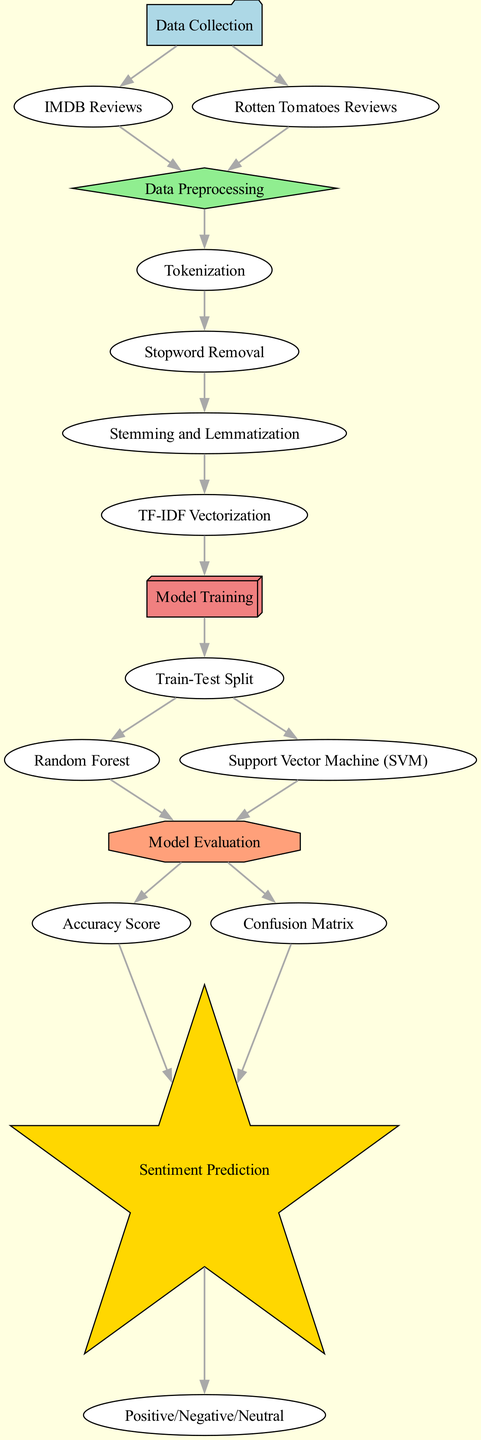What are the two sources of data collection? The diagram shows two sources for data collection: IMDB Reviews and Rotten Tomatoes Reviews as indicated by the edges leading from the "Data Collection" node to both sources.
Answer: IMDB Reviews, Rotten Tomatoes Reviews How many preprocessing steps are there in the diagram? The diagram includes four distinct steps labeled Tokenization, Stopword Removal, Stemming and Lemmatization, and TF-IDF Vectorization, which can be counted directly from the nodes connected to the Data Preprocessing node.
Answer: Four Which model training techniques are used in the diagram? The diagram specifies two techniques for model training: Random Forest and Support Vector Machine (SVM), which can be identified from the flow stemming from the Train-Test Split node leading to both models.
Answer: Random Forest, Support Vector Machine What follows model evaluation in the diagram? After the Model Evaluation step, the next actions are represented by the nodes for Accuracy Score and Confusion Matrix, which are outputs from the Model Evaluation node.
Answer: Accuracy Score, Confusion Matrix What is the final output of the diagram? The final output of the diagram is represented by the Positive/Negative/Neutral node, which is reached after processing through Sentiment Prediction, reflecting the categorization of sentiments.
Answer: Positive/Negative/Neutral Which step comes after Stemming and Lemmatization? The step that follows Stemming and Lemmatization in the diagram is TF-IDF Vectorization, which can be seen from the directed edge leading from the Stemming and Lemmatization node to the TF-IDF Vectorization node.
Answer: TF-IDF Vectorization How many nodes represent evaluation metrics? There are two nodes that represent evaluation metrics, namely Accuracy Score and Confusion Matrix, as shown in the diagram branching out from the Model Evaluation node.
Answer: Two What connects data collection to the preprocessing phase? The edges connecting Data Collection to Preprocessing are from the nodes IMDB Reviews and Rotten Tomatoes Reviews, indicating both sources of data flow into the Data Preprocessing step.
Answer: IMDB Reviews, Rotten Tomatoes Reviews 